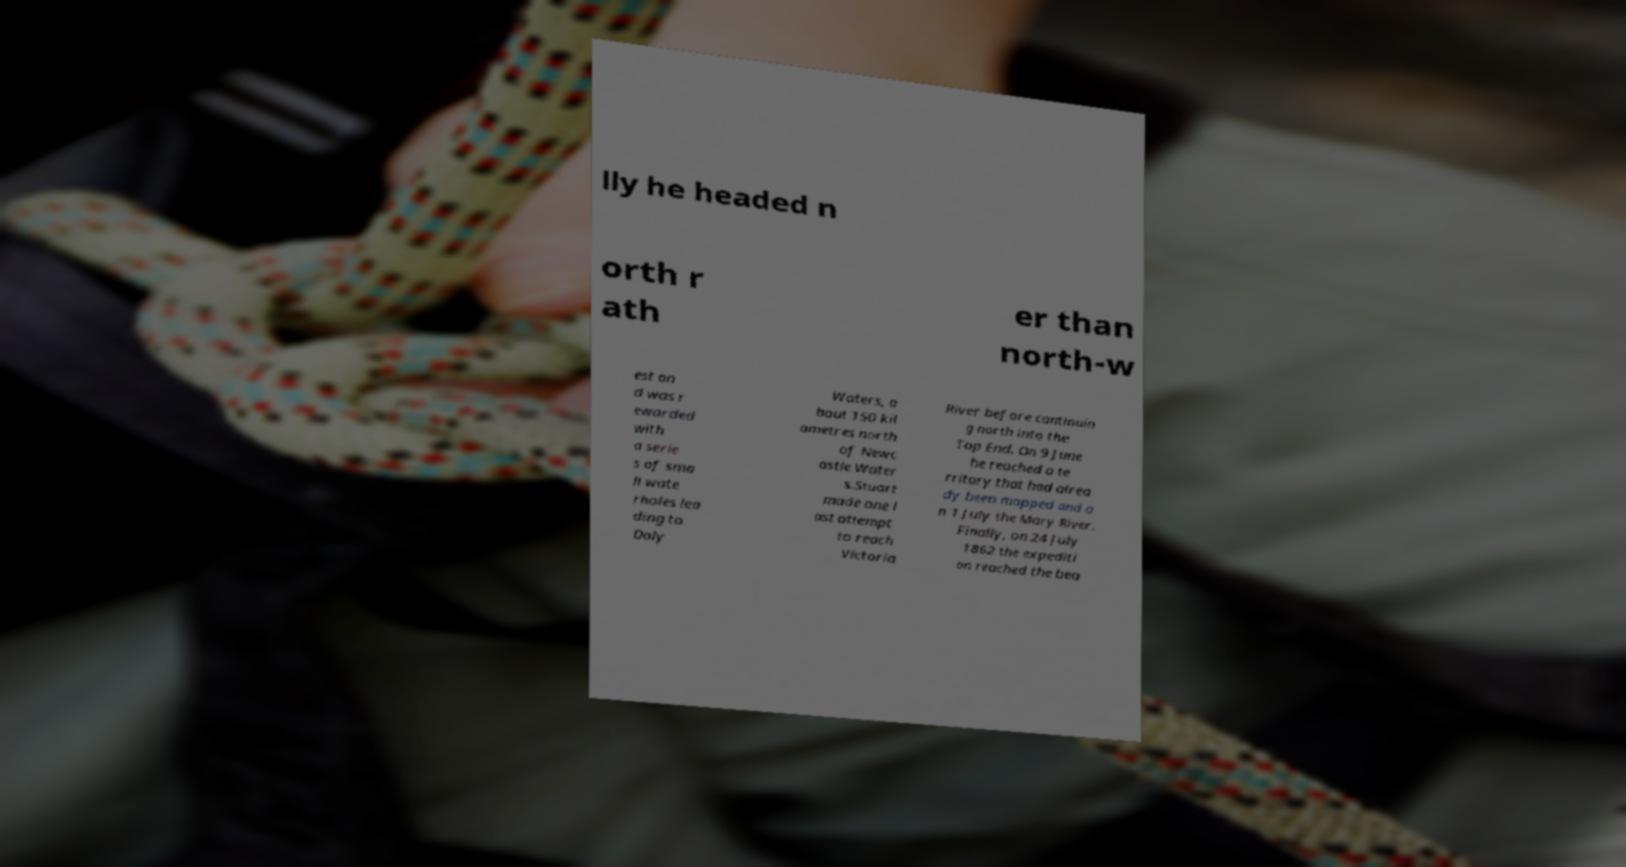Can you accurately transcribe the text from the provided image for me? lly he headed n orth r ath er than north-w est an d was r ewarded with a serie s of sma ll wate rholes lea ding to Daly Waters, a bout 150 kil ometres north of Newc astle Water s.Stuart made one l ast attempt to reach Victoria River before continuin g north into the Top End. On 9 June he reached a te rritory that had alrea dy been mapped and o n 1 July the Mary River. Finally, on 24 July 1862 the expediti on reached the bea 